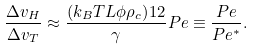Convert formula to latex. <formula><loc_0><loc_0><loc_500><loc_500>\frac { \Delta v _ { H } } { \Delta v _ { T } } \approx \frac { ( k _ { B } T L \phi \rho _ { c } ) ^ { } { 1 } 2 } { \gamma } P e \equiv \frac { P e } { P e ^ { * } } .</formula> 